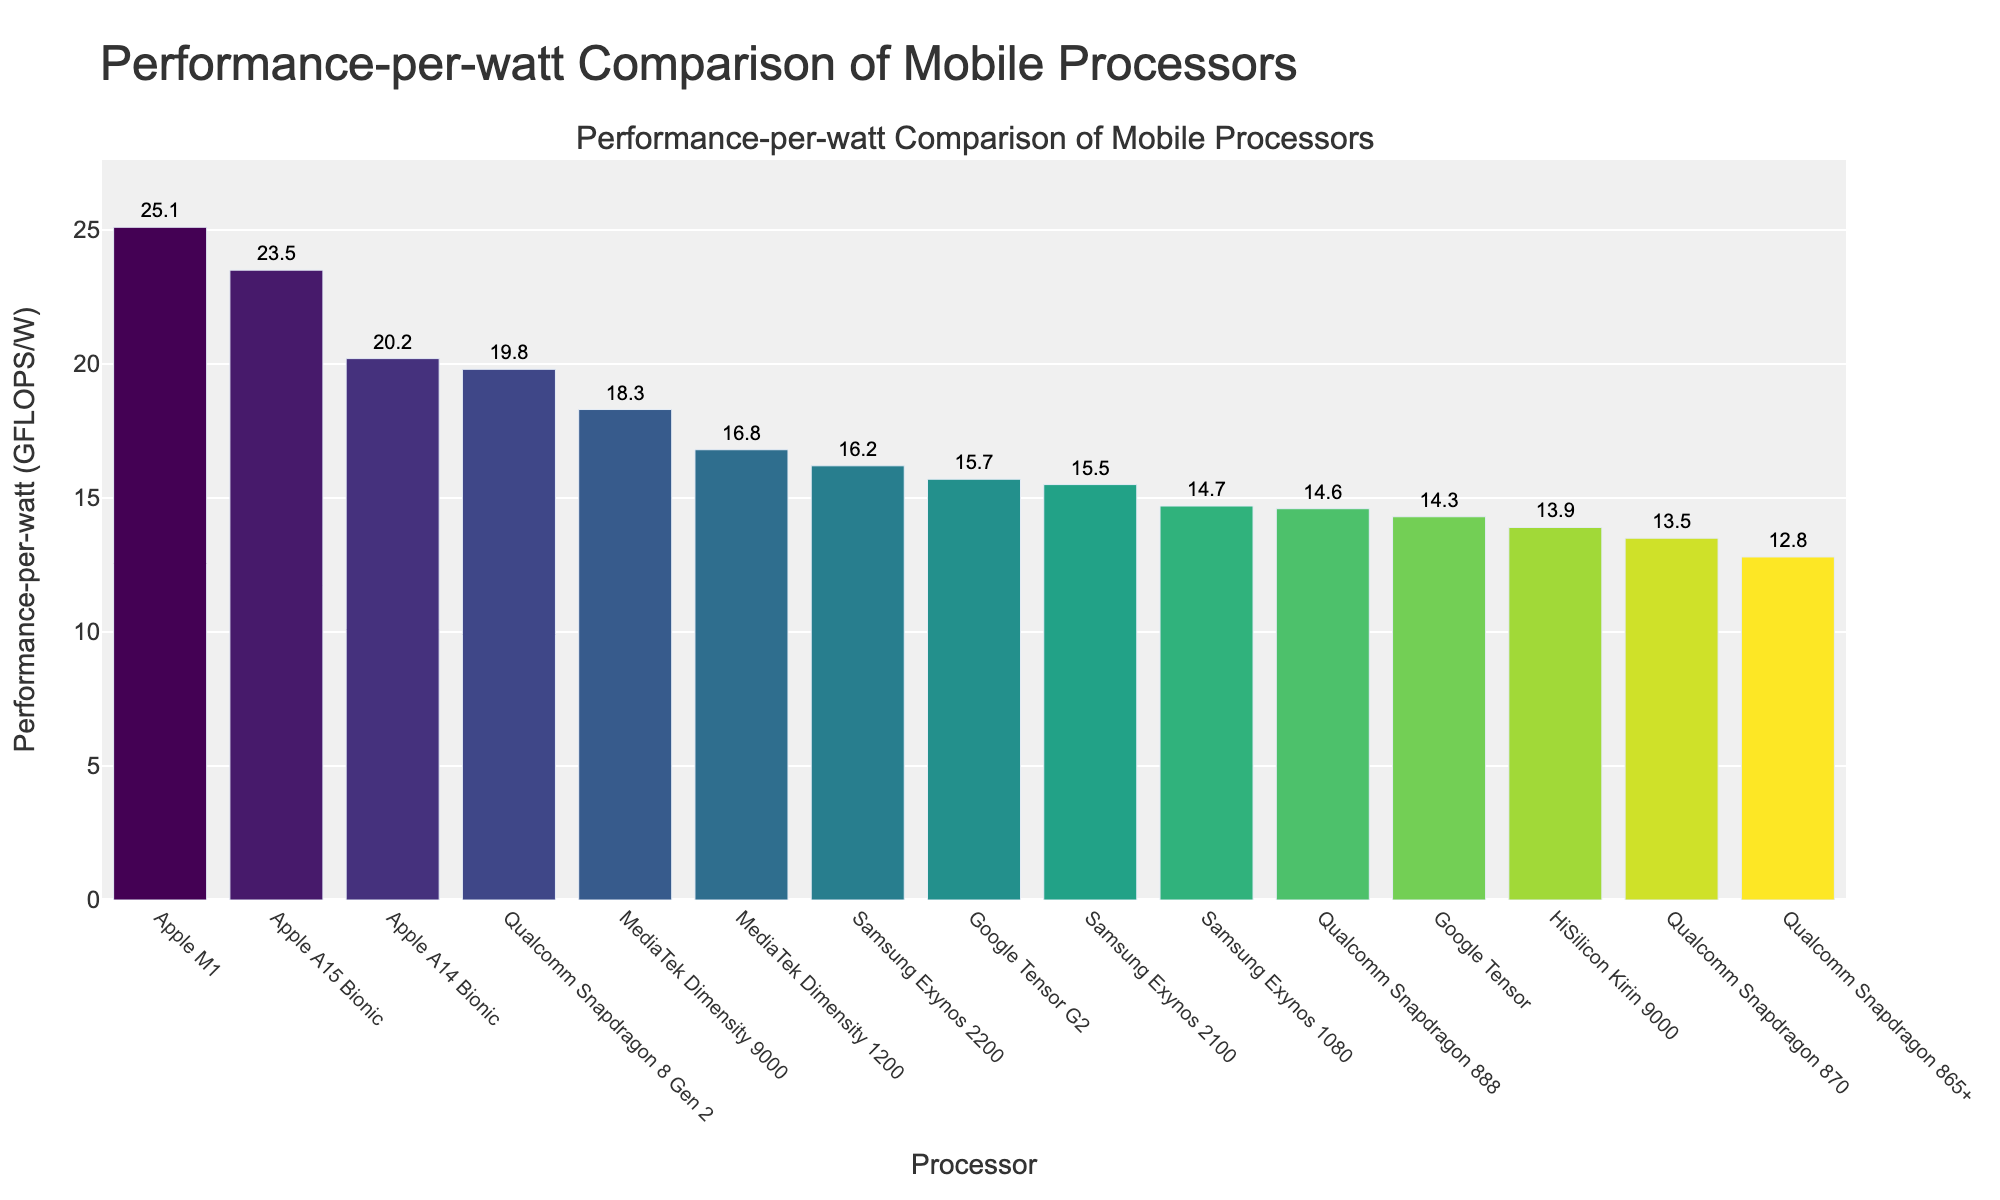What's the processor with the highest Performance-per-watt value? Look at the bar chart to identify the highest bar and read the processor name associated with it. The highest bar corresponds to the Apple M1 processor.
Answer: Apple M1 Which processor has the second lowest Performance-per-watt value? Identify the second shortest bar in the bar chart and check the processor name associated with it. The second shortest bar corresponds to the Qualcomm Snapdragon 870.
Answer: Qualcomm Snapdragon 870 What is the total Performance-per-watt of the top three processors? The top three processors are Apple M1 (25.1), Apple A15 Bionic (23.5), and Apple A14 Bionic (20.2). Sum their Performance-per-watt values: 25.1 + 23.5 + 20.2.
Answer: 68.8 Which processor performs better in terms of Performance-per-watt, Google Tensor G2 or Samsung Exynos 2200? Compare the heights of the bars for Google Tensor G2 and Samsung Exynos 2200. Samsung Exynos 2200 has a higher bar than Google Tensor G2.
Answer: Samsung Exynos 2200 How much higher is the Performance-per-watt of Qualcomm Snapdragon 8 Gen 2 compared to Qualcomm Snapdragon 888? Determine the Performance-per-watt values for Snapdragon 8 Gen 2 (19.8) and Snapdragon 888 (14.6). Calculate the difference: 19.8 - 14.6.
Answer: 5.2 What is the average Performance-per-watt of the processors from Qualcomm? Identify all Qualcomm processors and their Performance-per-watt values: Snapdragon 8 Gen 2 (19.8), Snapdragon 888 (14.6), Snapdragon 870 (13.5), and Snapdragon 865+ (12.8). Sum these values and divide by the number of Qualcomm processors: (19.8 + 14.6 + 13.5 + 12.8) / 4.
Answer: 15.175 Which processor has a Performance-per-watt value closest to 15? Identify the bars with Performance-per-watt values around 15. The processor closest to a Performance-per-watt value of 15 is Samsung Exynos 2100, with a value of 15.5.
Answer: Samsung Exynos 2100 How many processors have a Performance-per-watt value greater than 18? Count the number of bars with Performance-per-watt values exceeding 18. The processors are: Apple M1, Apple A15 Bionic, Qualcomm Snapdragon 8 Gen 2, and MediaTek Dimensity 9000, totaling 4.
Answer: 4 Which processor's bar is colored the darkest (lowest value on the colormap scale)? The colormap likely assigns darker colors to lower values. The processor with the lowest Performance-per-watt value will have the darkest bar, which is Qualcomm Snapdragon 865+.
Answer: Qualcomm Snapdragon 865+ What is the average Performance-per-watt for the four processors with the lowest values? Identify the four processors with the lowest Performance-per-watt values: Qualcomm Snapdragon 865+ (12.8), HiSilicon Kirin 9000 (13.9), Qualcomm Snapdragon 870 (13.5), and Google Tensor (14.3). Calculate the average: (12.8 + 13.9 + 13.5 + 14.3) / 4.
Answer: 13.625 